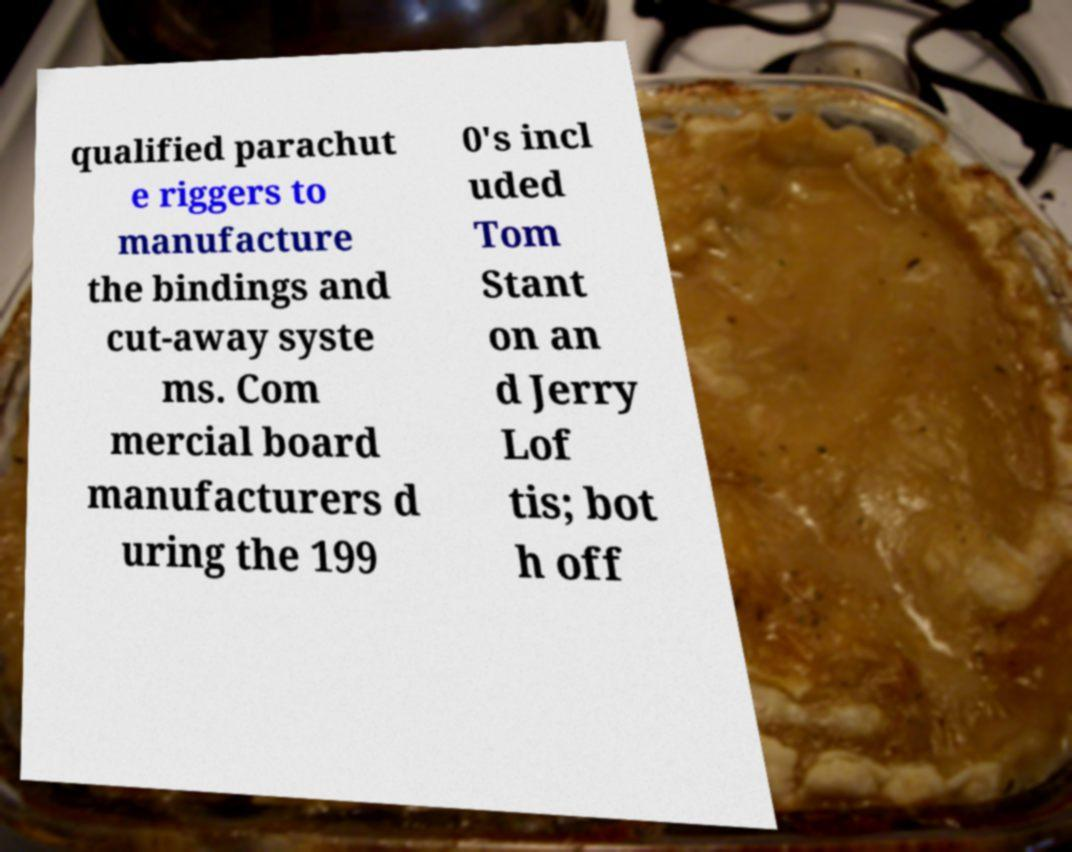Please identify and transcribe the text found in this image. qualified parachut e riggers to manufacture the bindings and cut-away syste ms. Com mercial board manufacturers d uring the 199 0's incl uded Tom Stant on an d Jerry Lof tis; bot h off 